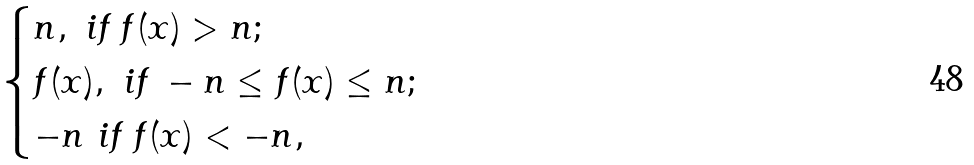Convert formula to latex. <formula><loc_0><loc_0><loc_500><loc_500>\begin{cases} n , \text { if } f ( x ) > n ; \\ f ( x ) , \text { if } - n \leq f ( x ) \leq n ; \\ - n \text { if } f ( x ) < - n , \end{cases}</formula> 